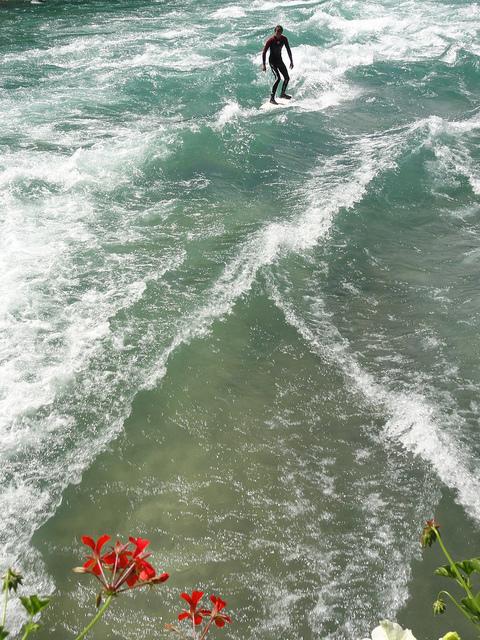Are there flowers in the water?
Be succinct. No. What is the man doing?
Write a very short answer. Surfing. Island nearby?
Keep it brief. Yes. 